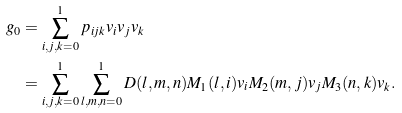<formula> <loc_0><loc_0><loc_500><loc_500>g _ { 0 } & = \sum _ { i , j , k = 0 } ^ { 1 } p _ { i j k } v _ { i } v _ { j } v _ { k } \\ & = \sum _ { i , j , k = 0 } ^ { 1 } \sum _ { l , m , n = 0 } ^ { 1 } D ( l , m , n ) M _ { 1 } ( l , i ) v _ { i } M _ { 2 } ( m , j ) v _ { j } M _ { 3 } ( n , k ) v _ { k } .</formula> 